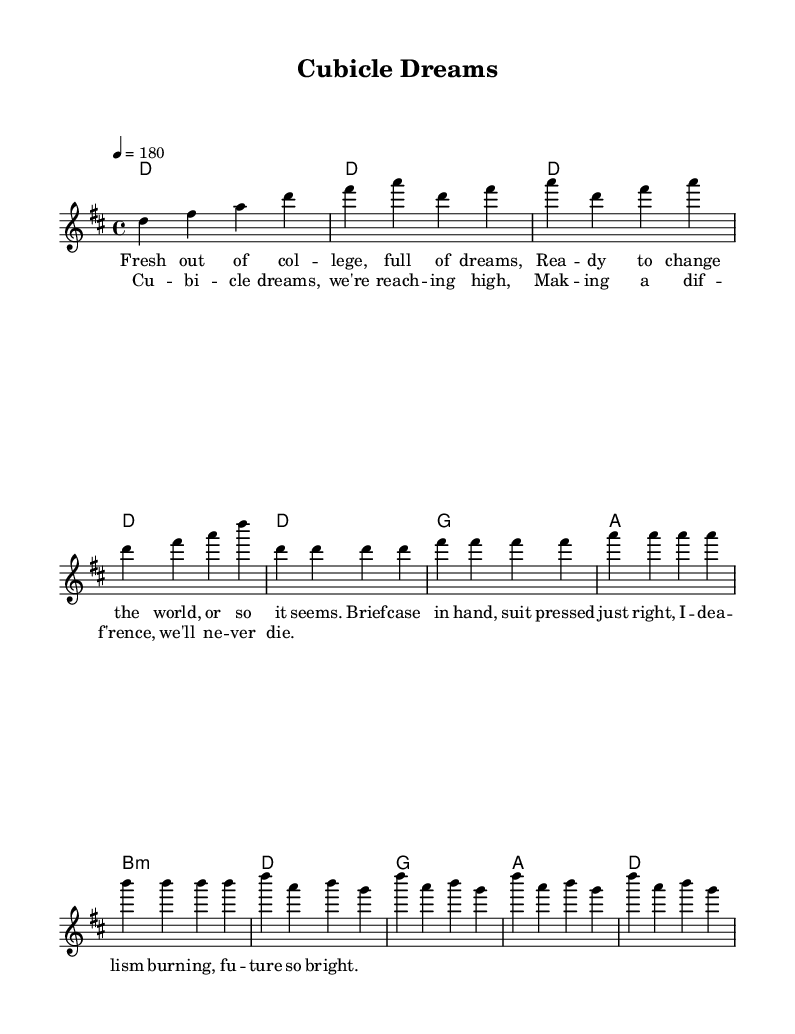What is the key signature of this music? The key signature indicated in the global section of the code is D major, which has two sharps: F# and C#.
Answer: D major What is the time signature of this music? The time signature is found in the global section of the code, which indicates a 4/4 time signature.
Answer: 4/4 What is the tempo marking for this piece? The tempo is given in the global section as 4 equals 180, meaning it is played at a pace of 180 beats per minute.
Answer: 180 How many measures are in the verse? The verse section is represented with four lines of music, each containing four measures, totaling 16 measures.
Answer: 16 What type of lyrical theme is expressed in the verse? The verse discusses themes related to recent college graduates and idealism, reflecting a desire to make a difference in the world.
Answer: Idealism What is the overall structure of the song? The song consists of an intro followed by a verse and then a chorus, making a repetitive structure typical for punk songs.
Answer: Intro, Verse, Chorus How does the chorus differ melodically from the verse? The chorus has a different melodic pattern and is generally more uplifting and anthemic, focusing on a collective ambition, contrasting with the personal reflections in the verse.
Answer: Uplifting 